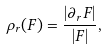<formula> <loc_0><loc_0><loc_500><loc_500>\rho _ { r } ( F ) = \frac { | \partial _ { r } F | } { | F | } ,</formula> 